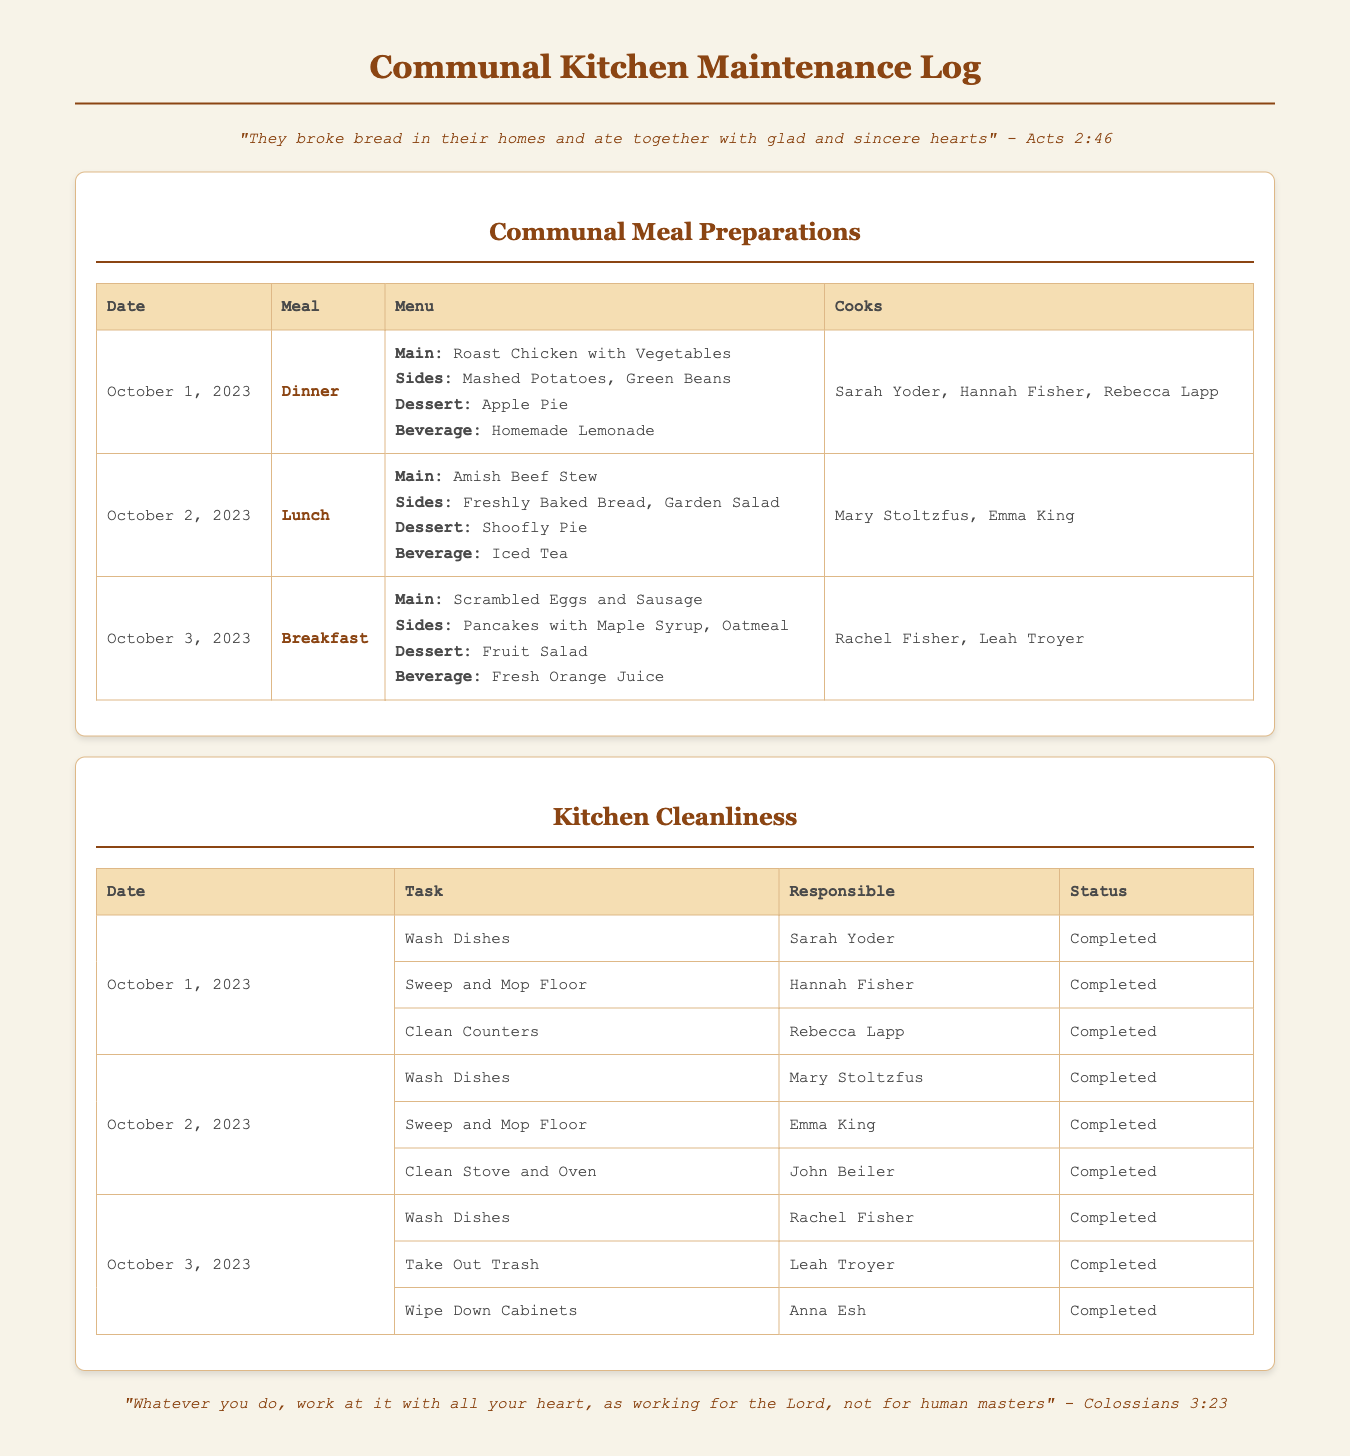What meal was prepared on October 1, 2023? The meal prepared on this date was Dinner, including Roast Chicken with Vegetables, Mashed Potatoes, Green Beans, Apple Pie, and Homemade Lemonade.
Answer: Dinner Who were the cooks for the meal on October 2, 2023? The cooks for the lunch on this date were Mary Stoltzfus and Emma King.
Answer: Mary Stoltzfus, Emma King What status is indicated for the task of cleaning the counters on October 1, 2023? The status for cleaning the counters on this date is "Completed".
Answer: Completed Which beverage was served with the breakfast on October 3, 2023? The beverage served with breakfast on this date was Fresh Orange Juice.
Answer: Fresh Orange Juice How many cleaning tasks were completed on October 2, 2023? There were three cleaning tasks completed on this date: washing dishes, sweeping and mopping the floor, and cleaning the stove and oven.
Answer: Three 